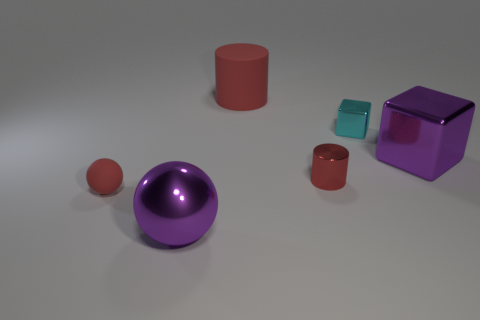Add 2 tiny red objects. How many objects exist? 8 Subtract all cubes. How many objects are left? 4 Add 4 red cylinders. How many red cylinders exist? 6 Subtract 0 gray balls. How many objects are left? 6 Subtract all cyan metal blocks. Subtract all red metal objects. How many objects are left? 4 Add 6 small balls. How many small balls are left? 7 